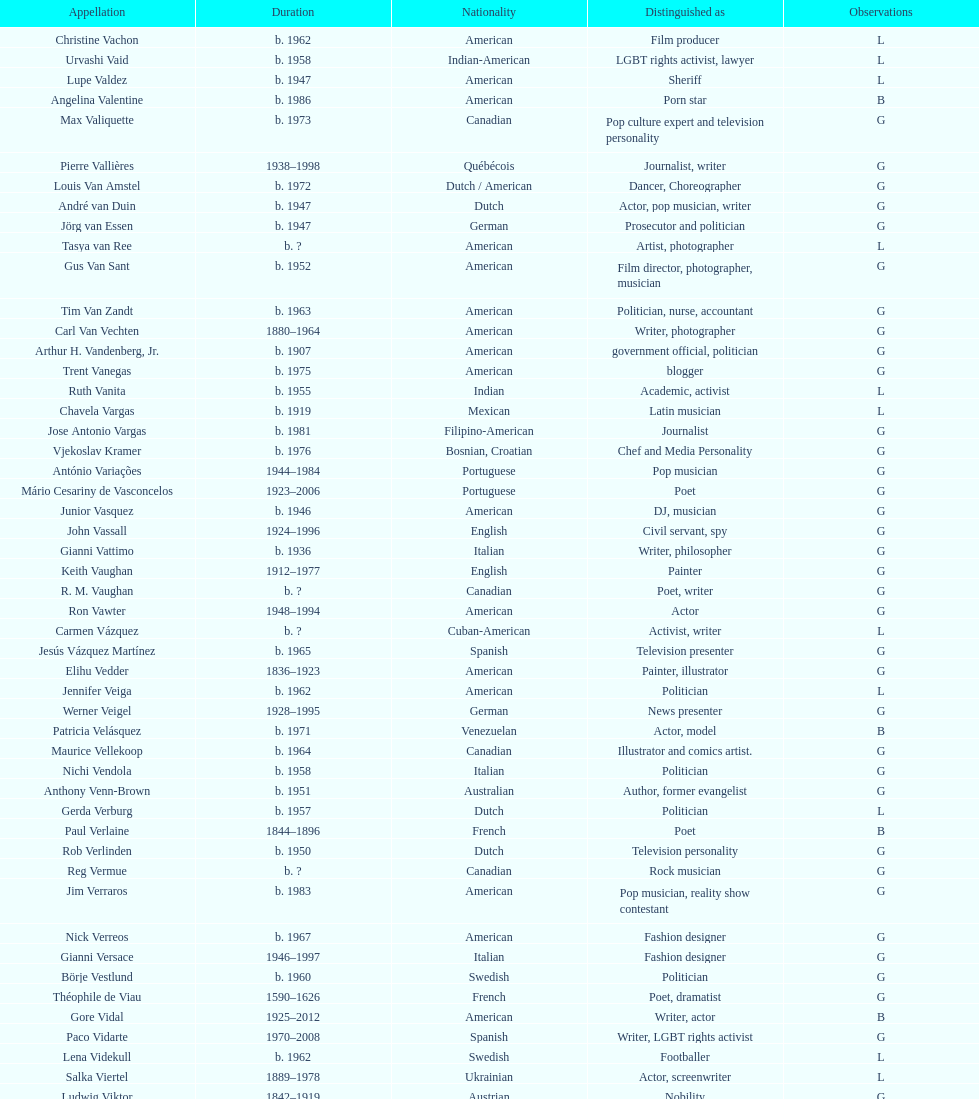Patricia velasquez and ron vawter both had what career? Actor. 